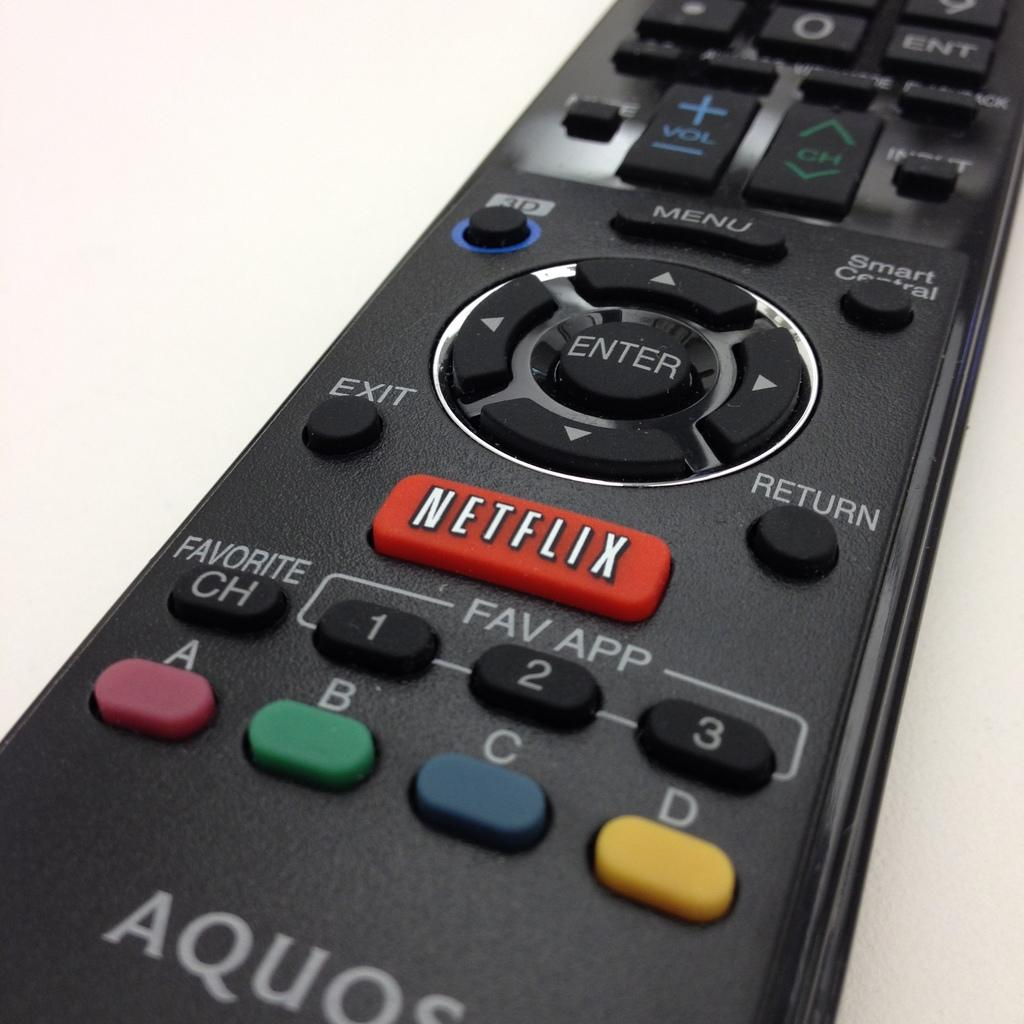<image>
Summarize the visual content of the image. the name Netflix on the front of a remote 